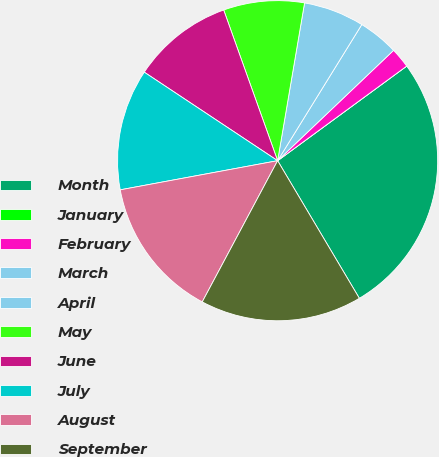<chart> <loc_0><loc_0><loc_500><loc_500><pie_chart><fcel>Month<fcel>January<fcel>February<fcel>March<fcel>April<fcel>May<fcel>June<fcel>July<fcel>August<fcel>September<nl><fcel>26.53%<fcel>0.0%<fcel>2.04%<fcel>4.08%<fcel>6.12%<fcel>8.16%<fcel>10.2%<fcel>12.24%<fcel>14.28%<fcel>16.33%<nl></chart> 